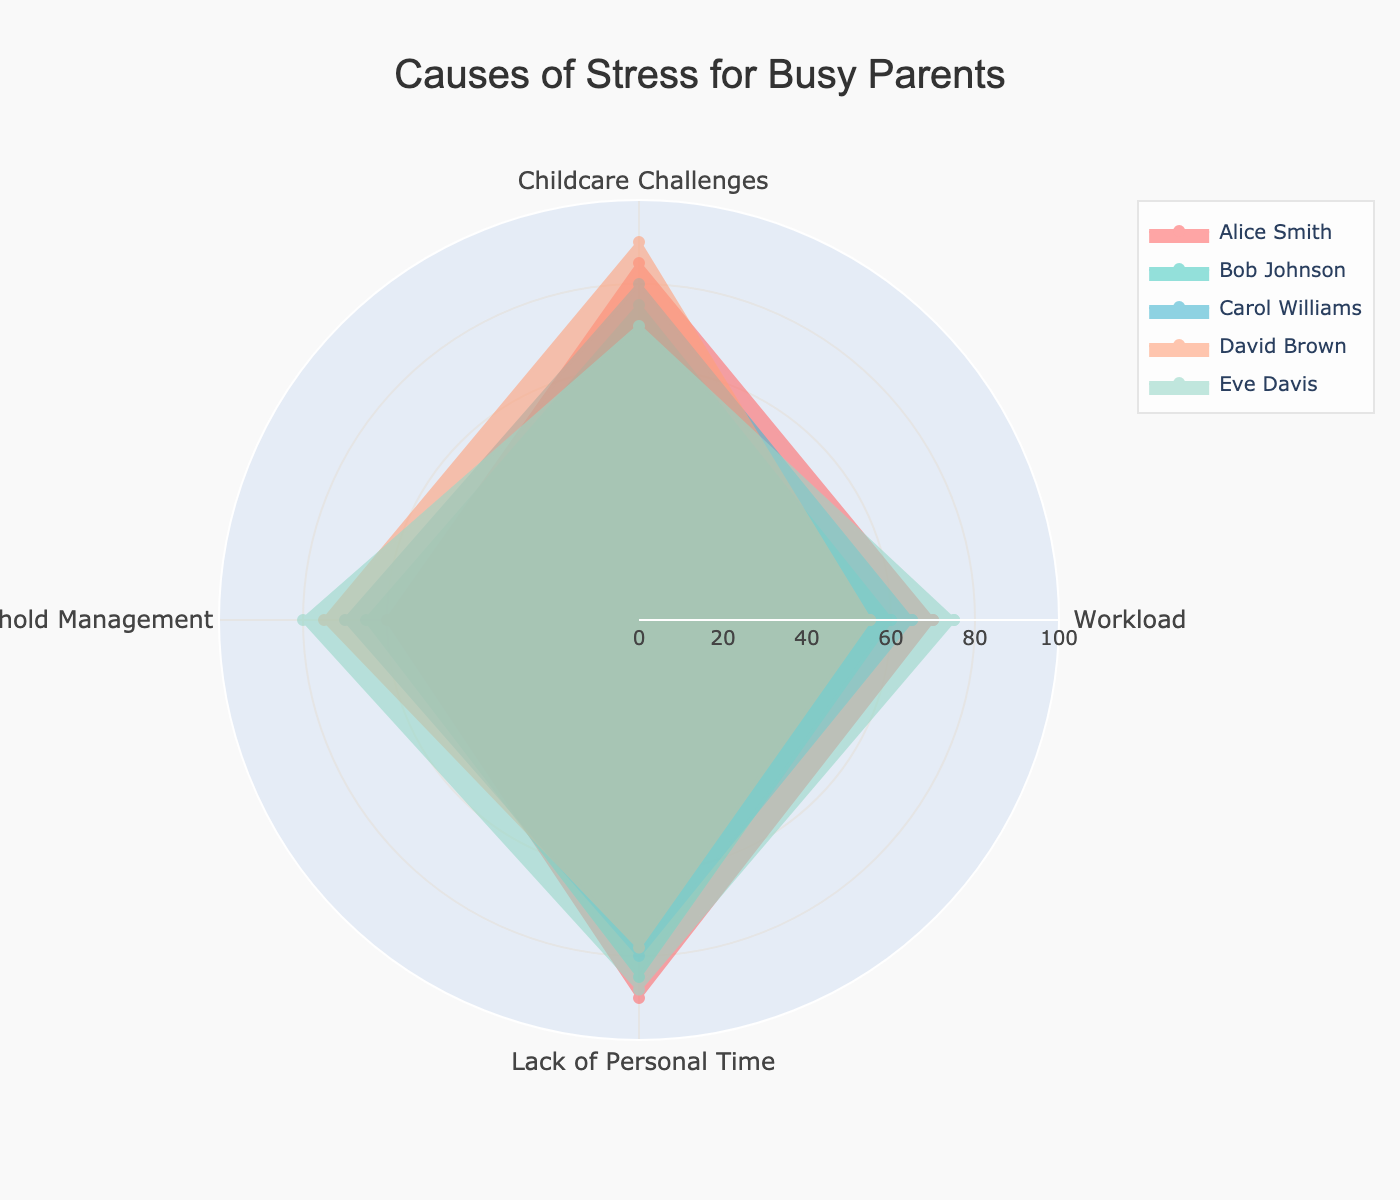What's the title of the radar chart? The title of the chart is displayed at the top center of the plot. It reads "Causes of Stress for Busy Parents".
Answer: Causes of Stress for Busy Parents How many categories of stress are displayed? There are four categories listed around the circumference of the radar chart: Workload, Childcare Challenges, Household Management, and Lack of Personal Time.
Answer: Four Which individual reports the highest level of stress in "Childcare Challenges"? Looking at the "Childcare Challenges" axis, David Brown has the highest value at 90.
Answer: David Brown What is the average stress level for Alice Smith? Alice Smith's stress levels are (70 for Workload, 85 for Childcare Challenges, 60 for Household Management, 90 for Lack of Personal Time). The average is (70+85+60+90)/4 = 76.25.
Answer: 76.25 Who has the lowest stress level in "Household Management"? On the "Household Management" axis, Alice Smith has the lowest value at 60.
Answer: Alice Smith What is the combined stress level of Carol Williams across all categories? The stress levels for Carol Williams are (65 for Workload, 80 for Childcare Challenges, 70 for Household Management, 80 for Lack of Personal Time). Combined, they total (65+80+70+80) = 295.
Answer: 295 Who has more stress in "Lack of Personal Time," Bob Johnson or Eve Davis? Bob Johnson has a score of 85 for "Lack of Personal Time," while Eve Davis has a score of 88. Eve Davis has more stress.
Answer: Eve Davis Which individual has the smallest range of stress levels across all categories, and what is the range? To find this, we calculate the range (max value - min value) for each individual:
- Alice Smith: 90 - 60 = 30
- Bob Johnson: 85 - 60 = 25
- Carol Williams: 80 - 65 = 15
- David Brown: 90 - 55 = 35
- Eve Davis: 88 - 70 = 18
Carol Williams has the smallest range of 15.
Answer: Carol Williams, 15 Which stress category has the highest average stress level across all individuals? Calculate the average for each category:
- Workload: (70+60+65+55+75)/5 = 65
- Childcare Challenges: (85+75+80+90+70)/5 = 80
- Household Management: (60+65+70+75+80)/5 = 70
- Lack of Personal Time: (90+85+80+78+88)/5 = 84.2
"Lack of Personal Time" has the highest average stress level at 84.2.
Answer: Lack of Personal Time 